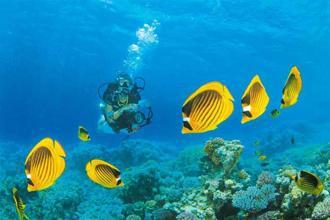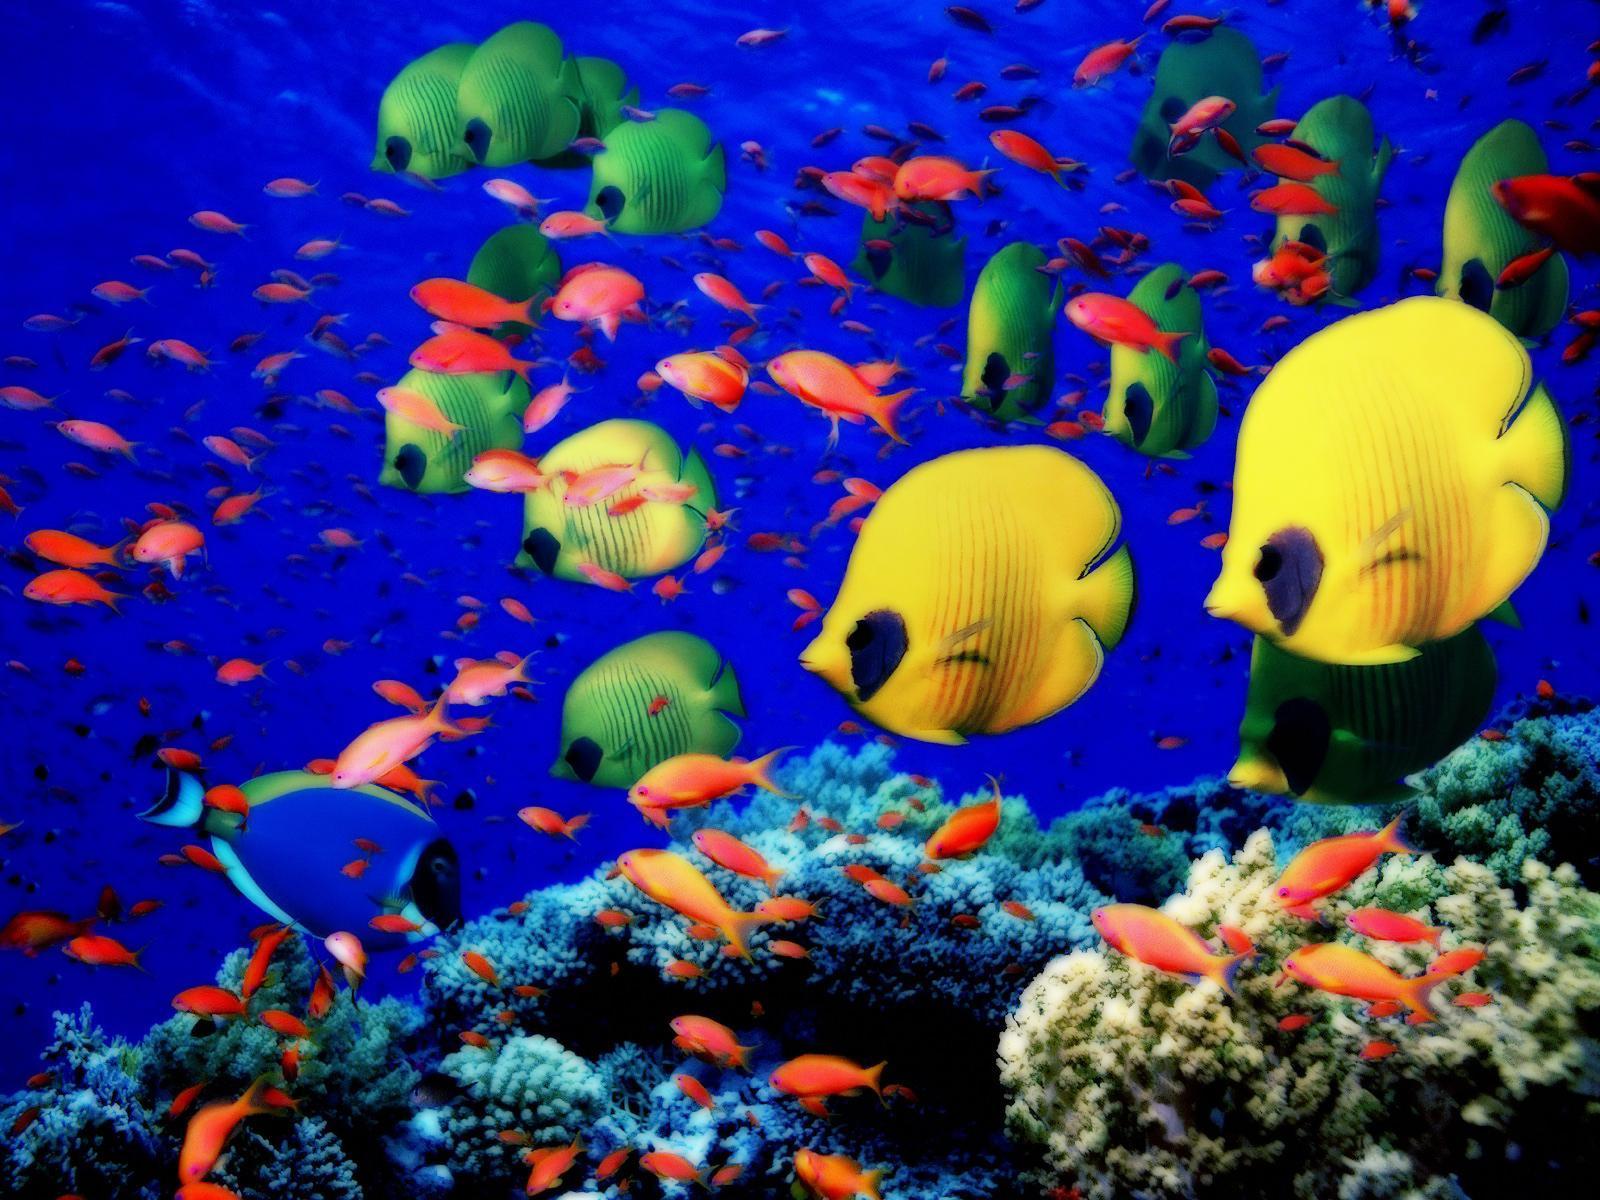The first image is the image on the left, the second image is the image on the right. For the images shown, is this caption "The left and right image contains the same number of striped fish faces." true? Answer yes or no. No. The first image is the image on the left, the second image is the image on the right. Given the left and right images, does the statement "The left image contains exactly two fish, which are orange with at least one white stripe, swimming face-forward in anemone tendrils." hold true? Answer yes or no. No. 